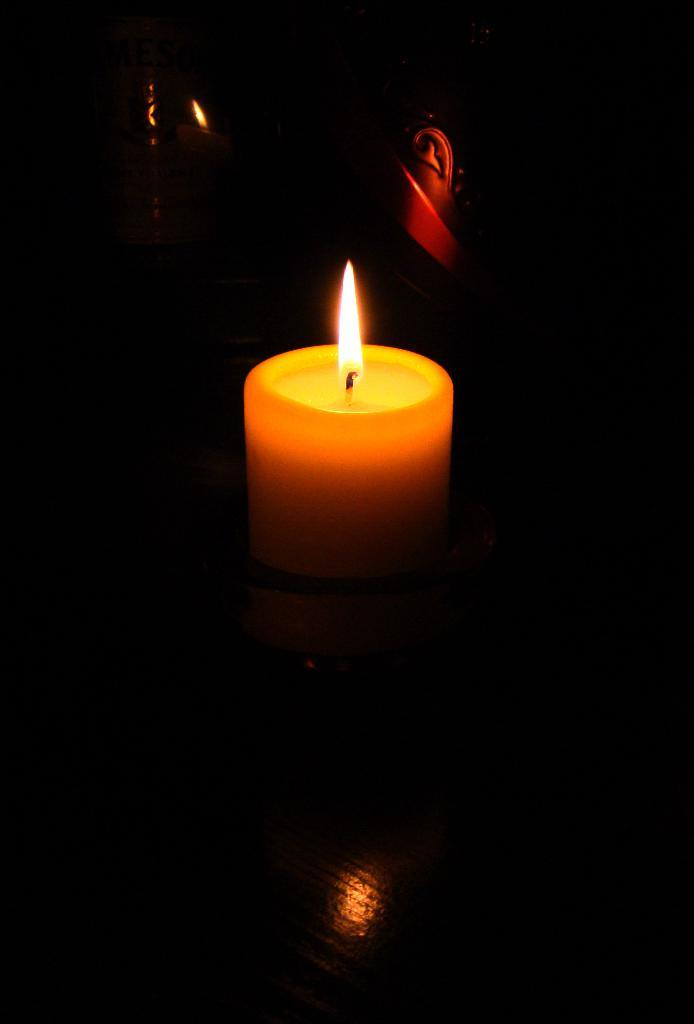What object is the main subject of the image? There is a candle in the image. Where is the candle located? The candle is placed on a table. What can be observed about the lighting in the image? The background of the image is dark. What type of birth certificate can be seen in the image? There is no birth certificate present in the image; it features a candle on a table with a dark background. 